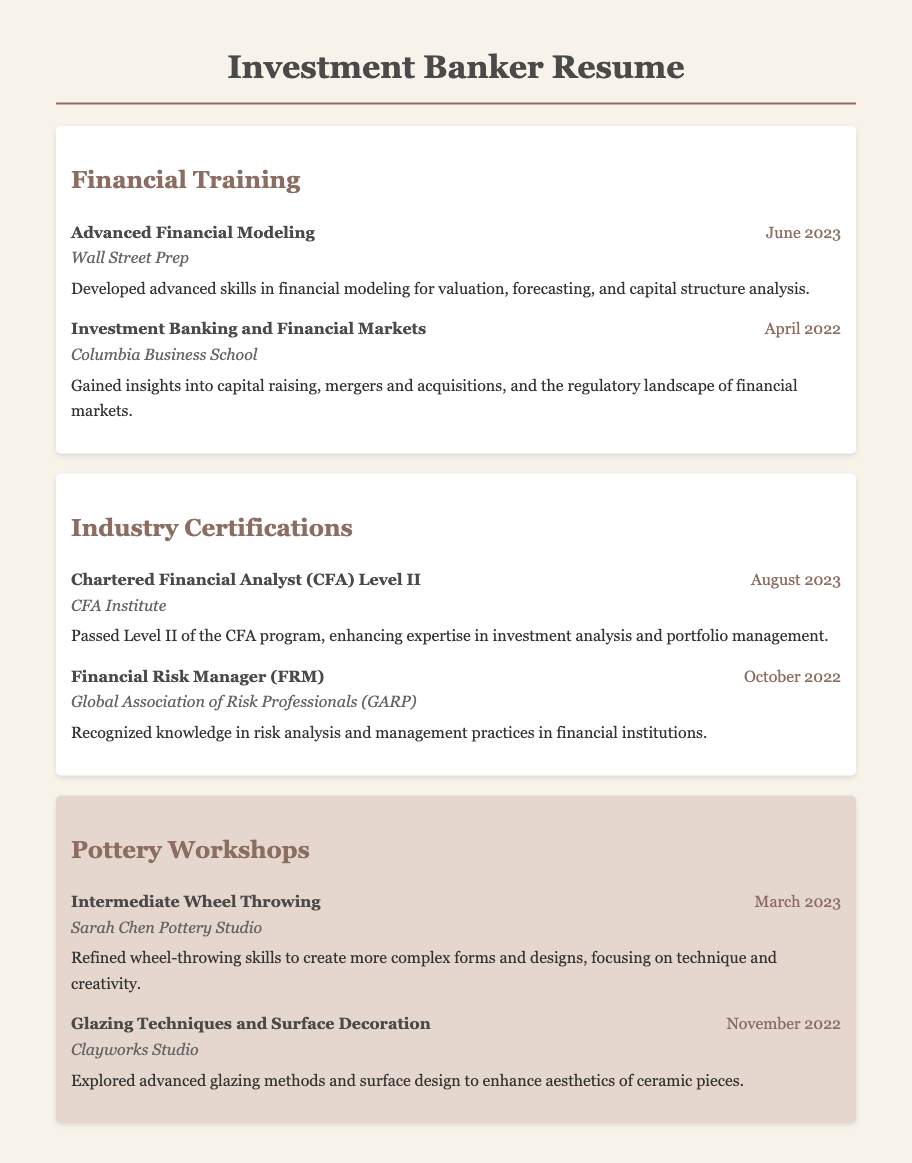what is the title of the most recent financial training attended? The most recent financial training listed is "Advanced Financial Modeling," which occurred in June 2023.
Answer: Advanced Financial Modeling what certification was passed in August 2023? The certification passed in August 2023 is "Chartered Financial Analyst (CFA) Level II."
Answer: Chartered Financial Analyst (CFA) Level II who conducted the Intermediate Wheel Throwing workshop? The Intermediate Wheel Throwing workshop was conducted by Sarah Chen Pottery Studio.
Answer: Sarah Chen Pottery Studio what was the date of the Glazing Techniques and Surface Decoration workshop? The Glazing Techniques and Surface Decoration workshop took place in November 2022.
Answer: November 2022 how many financial training sessions are detailed in the document? There are two financial training sessions outlined in the document.
Answer: 2 which certification is associated with risk management? The certification associated with risk management is "Financial Risk Manager (FRM)."
Answer: Financial Risk Manager (FRM) what is the main focus of the Advanced Financial Modeling training? The main focus of the Advanced Financial Modeling training is on valuation, forecasting, and capital structure analysis.
Answer: Valuation, forecasting, and capital structure analysis how many pottery workshops are listed in the document? There are two pottery workshops listed in the document.
Answer: 2 